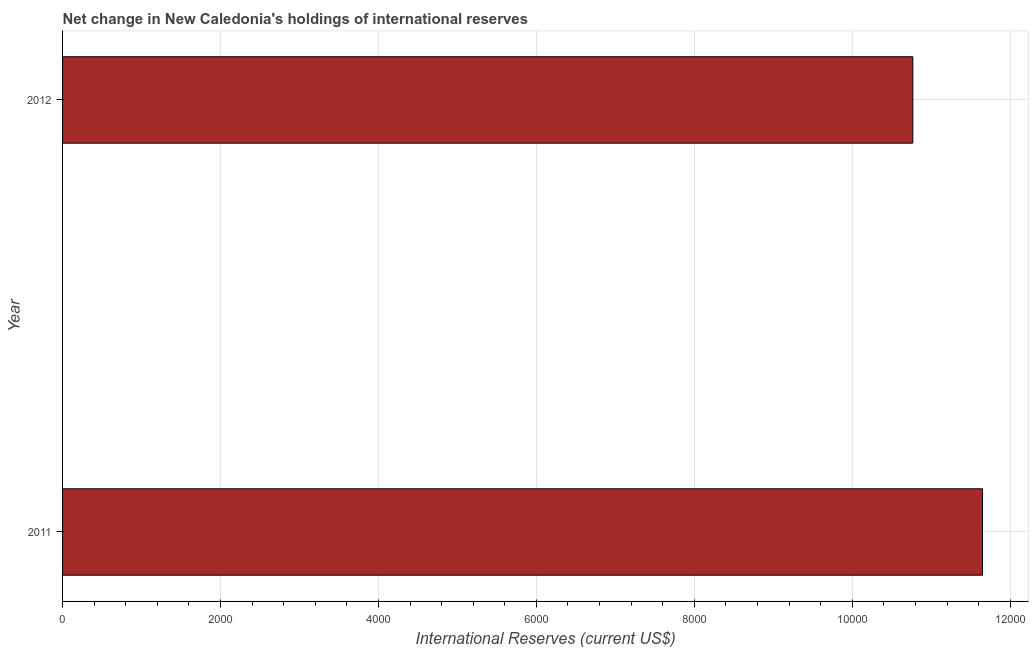Does the graph contain any zero values?
Your response must be concise. No. What is the title of the graph?
Keep it short and to the point. Net change in New Caledonia's holdings of international reserves. What is the label or title of the X-axis?
Your answer should be compact. International Reserves (current US$). What is the reserves and related items in 2012?
Ensure brevity in your answer.  1.08e+04. Across all years, what is the maximum reserves and related items?
Your answer should be very brief. 1.16e+04. Across all years, what is the minimum reserves and related items?
Keep it short and to the point. 1.08e+04. In which year was the reserves and related items maximum?
Keep it short and to the point. 2011. In which year was the reserves and related items minimum?
Your answer should be very brief. 2012. What is the sum of the reserves and related items?
Make the answer very short. 2.24e+04. What is the difference between the reserves and related items in 2011 and 2012?
Keep it short and to the point. 882.18. What is the average reserves and related items per year?
Offer a terse response. 1.12e+04. What is the median reserves and related items?
Give a very brief answer. 1.12e+04. Do a majority of the years between 2011 and 2012 (inclusive) have reserves and related items greater than 10000 US$?
Provide a short and direct response. Yes. What is the ratio of the reserves and related items in 2011 to that in 2012?
Your answer should be compact. 1.08. Is the reserves and related items in 2011 less than that in 2012?
Provide a short and direct response. No. In how many years, is the reserves and related items greater than the average reserves and related items taken over all years?
Provide a short and direct response. 1. How many bars are there?
Your answer should be very brief. 2. Are all the bars in the graph horizontal?
Make the answer very short. Yes. What is the difference between two consecutive major ticks on the X-axis?
Your answer should be very brief. 2000. Are the values on the major ticks of X-axis written in scientific E-notation?
Keep it short and to the point. No. What is the International Reserves (current US$) of 2011?
Keep it short and to the point. 1.16e+04. What is the International Reserves (current US$) in 2012?
Provide a short and direct response. 1.08e+04. What is the difference between the International Reserves (current US$) in 2011 and 2012?
Keep it short and to the point. 882.18. What is the ratio of the International Reserves (current US$) in 2011 to that in 2012?
Your answer should be very brief. 1.08. 